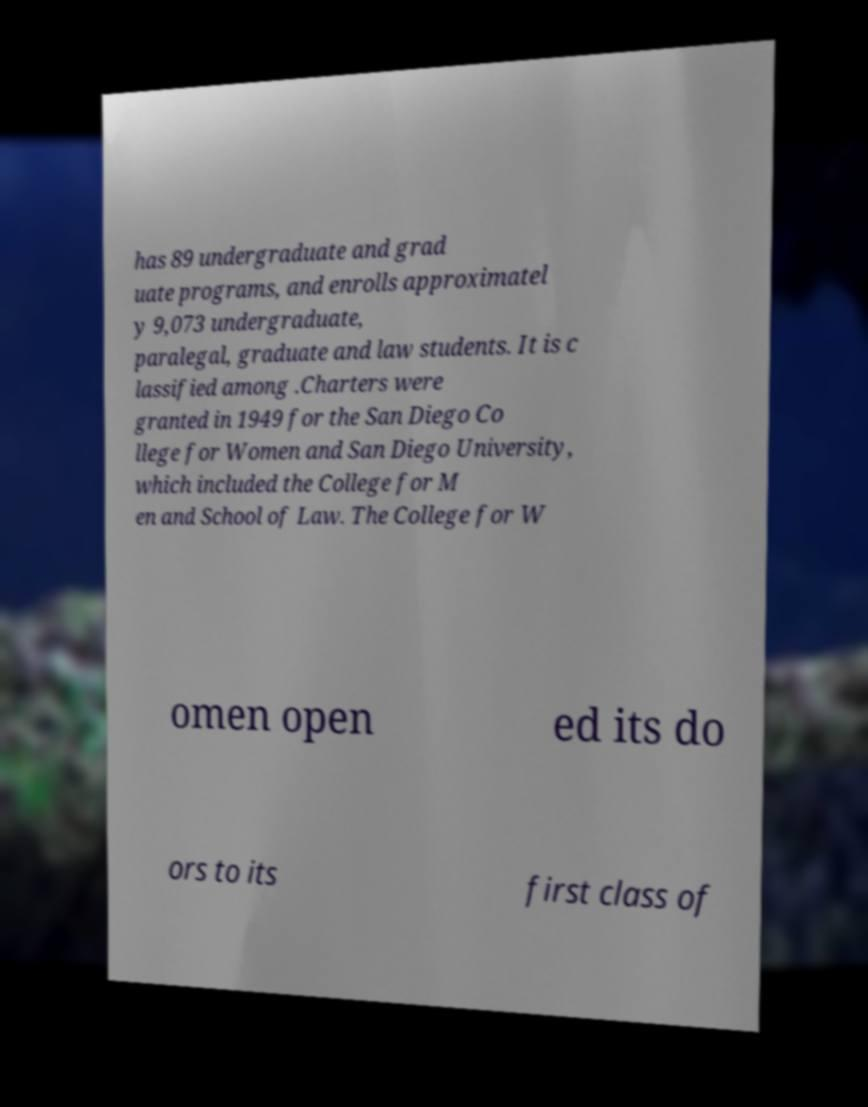Could you assist in decoding the text presented in this image and type it out clearly? has 89 undergraduate and grad uate programs, and enrolls approximatel y 9,073 undergraduate, paralegal, graduate and law students. It is c lassified among .Charters were granted in 1949 for the San Diego Co llege for Women and San Diego University, which included the College for M en and School of Law. The College for W omen open ed its do ors to its first class of 